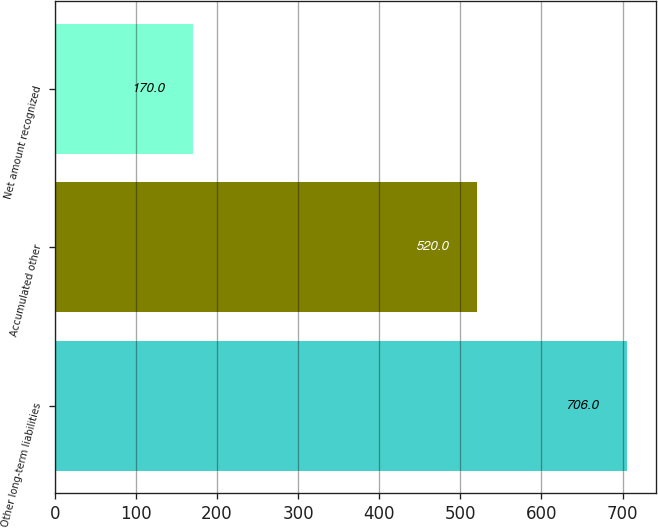<chart> <loc_0><loc_0><loc_500><loc_500><bar_chart><fcel>Other long-term liabilities<fcel>Accumulated other<fcel>Net amount recognized<nl><fcel>706<fcel>520<fcel>170<nl></chart> 